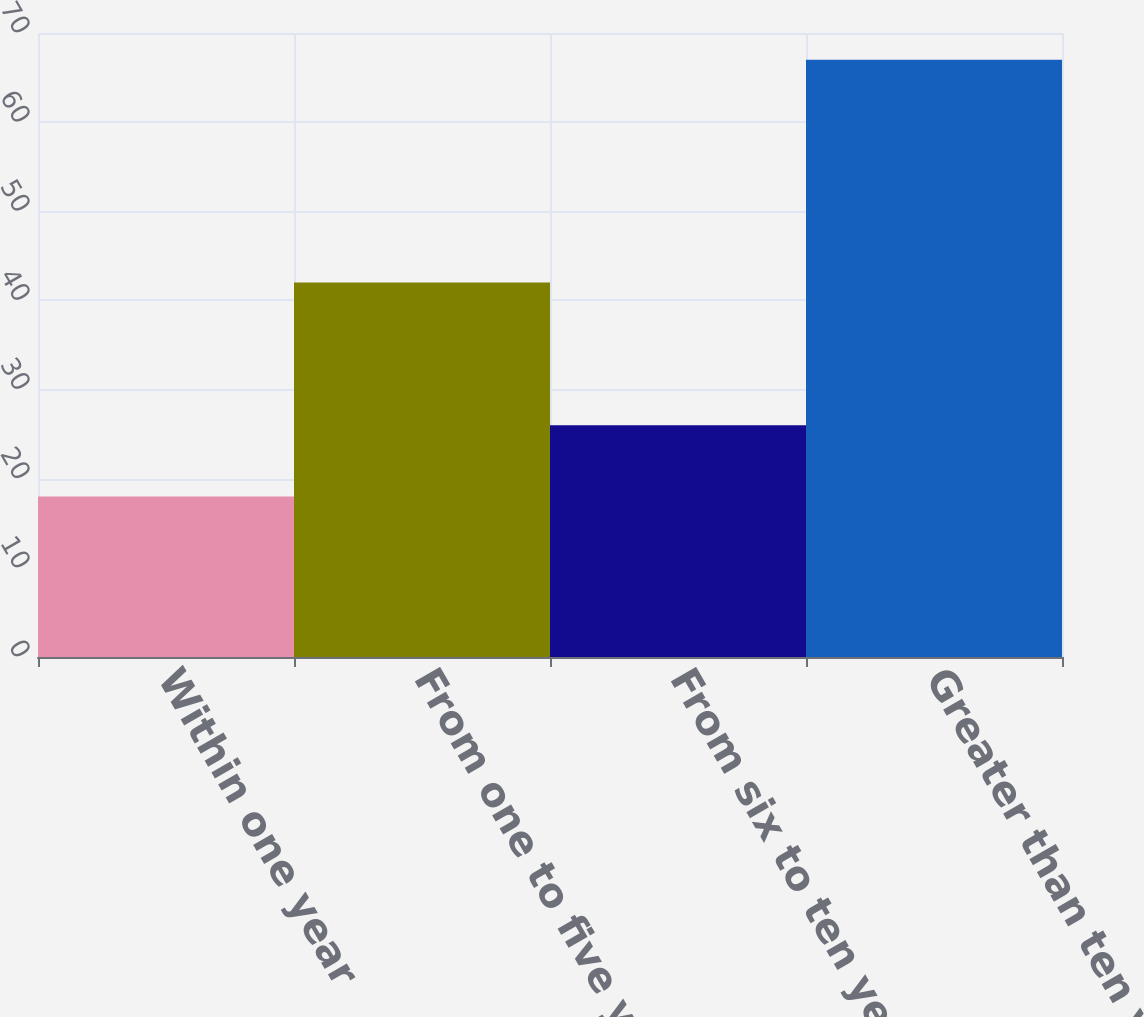<chart> <loc_0><loc_0><loc_500><loc_500><bar_chart><fcel>Within one year<fcel>From one to five years<fcel>From six to ten years<fcel>Greater than ten years<nl><fcel>18<fcel>42<fcel>26<fcel>67<nl></chart> 